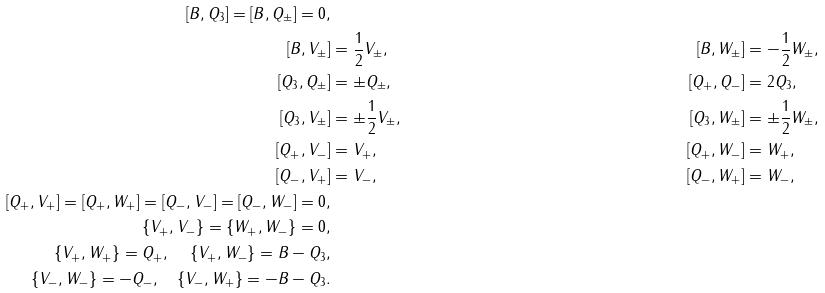Convert formula to latex. <formula><loc_0><loc_0><loc_500><loc_500>[ B , Q _ { 3 } ] = [ B , Q _ { \pm } ] = 0 , \\ [ B , V _ { \pm } ] & = \frac { 1 } { 2 } V _ { \pm } , & [ B , W _ { \pm } ] & = - \frac { 1 } { 2 } W _ { \pm } , \\ [ Q _ { 3 } , Q _ { \pm } ] & = \pm Q _ { \pm } , & [ Q _ { + } , Q _ { - } ] & = 2 Q _ { 3 } , \\ [ Q _ { 3 } , V _ { \pm } ] & = \pm \frac { 1 } { 2 } V _ { \pm } , & [ Q _ { 3 } , W _ { \pm } ] & = \pm \frac { 1 } { 2 } W _ { \pm } , \\ [ Q _ { + } , V _ { - } ] & = V _ { + } , & [ Q _ { + } , W _ { - } ] & = W _ { + } , \\ [ Q _ { - } , V _ { + } ] & = V _ { - } , & [ Q _ { - } , W _ { + } ] & = W _ { - } , \\ [ Q _ { + } , V _ { + } ] = [ Q _ { + } , W _ { + } ] = [ Q _ { - } , V _ { - } ] = [ Q _ { - } , W _ { - } ] = 0 , \\ \{ V _ { + } , V _ { - } \} = \{ W _ { + } , W _ { - } \} = 0 , \\ \{ V _ { + } , W _ { + } \} = Q _ { + } , \quad \, \{ V _ { + } , W _ { - } \} = B - Q _ { 3 } , \\ \{ V _ { - } , W _ { - } \} = - Q _ { - } , \quad \{ V _ { - } , W _ { + } \} = - B - Q _ { 3 } .</formula> 